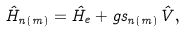Convert formula to latex. <formula><loc_0><loc_0><loc_500><loc_500>\hat { H } _ { n ( m ) } = \hat { H } _ { e } + g s _ { n ( m ) } \hat { V } ,</formula> 